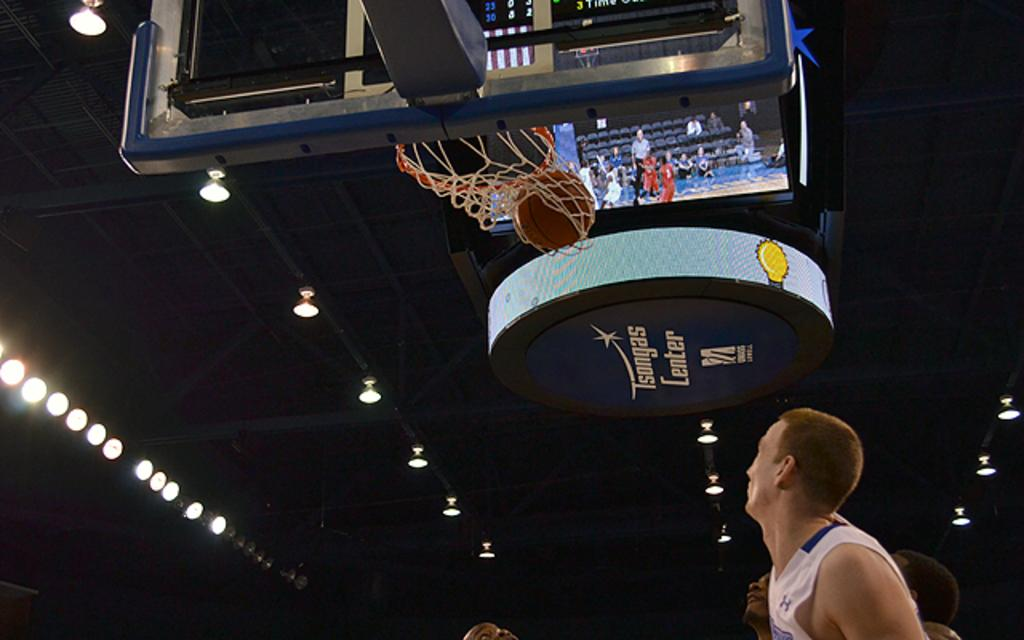<image>
Give a short and clear explanation of the subsequent image. Basketball players watch a basketball going through the net at Tsongas Center. 